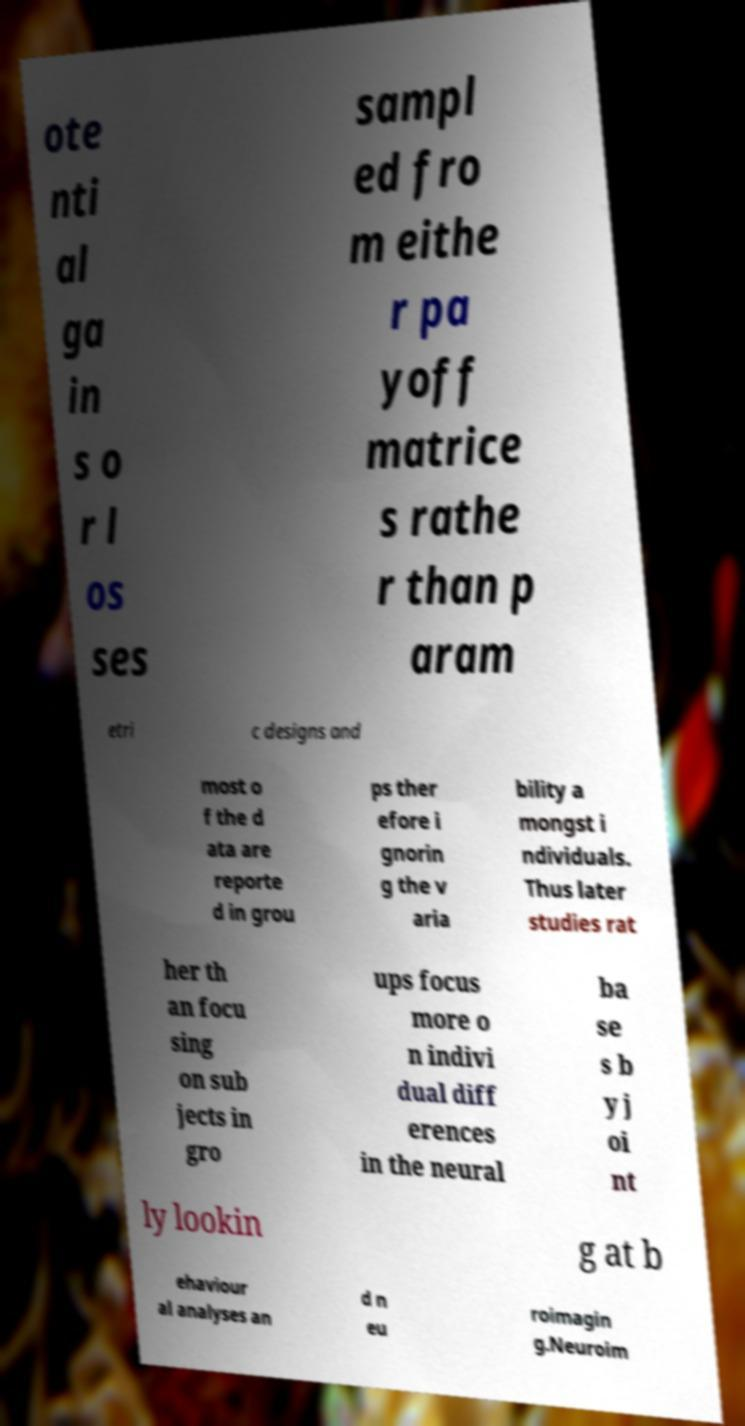Please identify and transcribe the text found in this image. ote nti al ga in s o r l os ses sampl ed fro m eithe r pa yoff matrice s rathe r than p aram etri c designs and most o f the d ata are reporte d in grou ps ther efore i gnorin g the v aria bility a mongst i ndividuals. Thus later studies rat her th an focu sing on sub jects in gro ups focus more o n indivi dual diff erences in the neural ba se s b y j oi nt ly lookin g at b ehaviour al analyses an d n eu roimagin g.Neuroim 